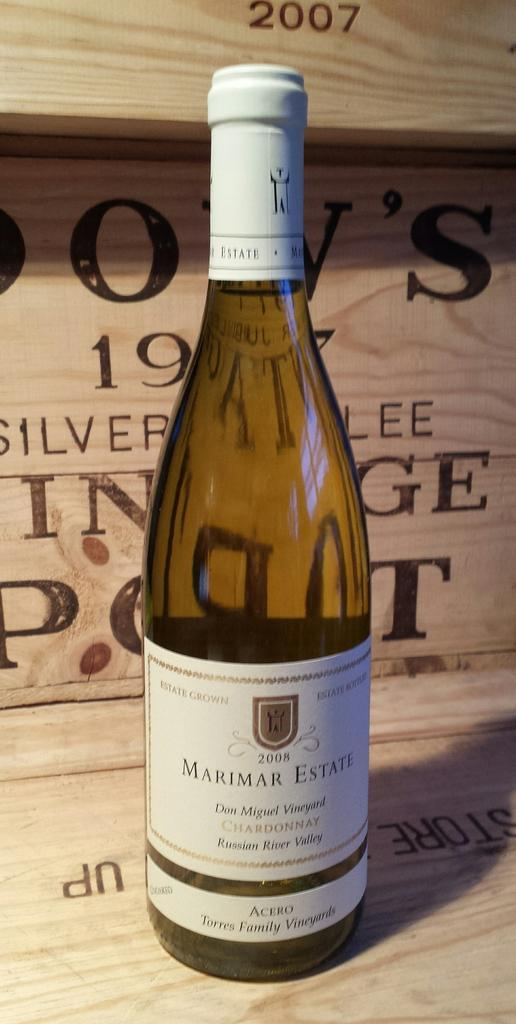<image>
Summarize the visual content of the image. Bottle with a white label that says the year 2008 on it. 